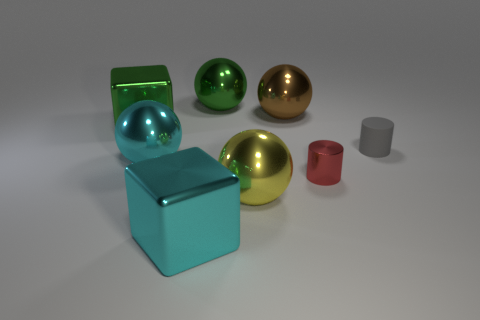Subtract all yellow balls. Subtract all gray cylinders. How many balls are left? 3 Add 2 cylinders. How many objects exist? 10 Subtract all cylinders. How many objects are left? 6 Add 5 metallic balls. How many metallic balls exist? 9 Subtract 1 yellow balls. How many objects are left? 7 Subtract all large yellow rubber cubes. Subtract all tiny red metal cylinders. How many objects are left? 7 Add 3 tiny red objects. How many tiny red objects are left? 4 